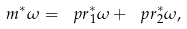Convert formula to latex. <formula><loc_0><loc_0><loc_500><loc_500>m ^ { * } \omega = \ p r _ { 1 } ^ { * } \omega + \ p r _ { 2 } ^ { * } \omega ,</formula> 